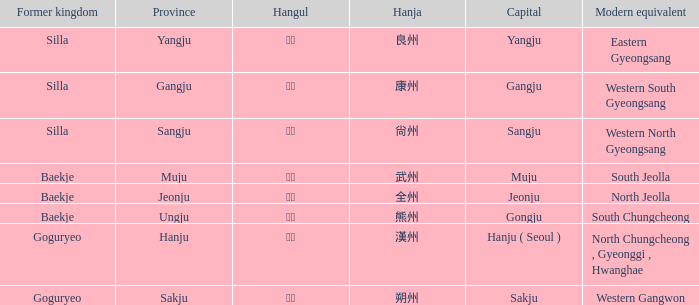What is the hanja for the province of "sangju"? 尙州. 